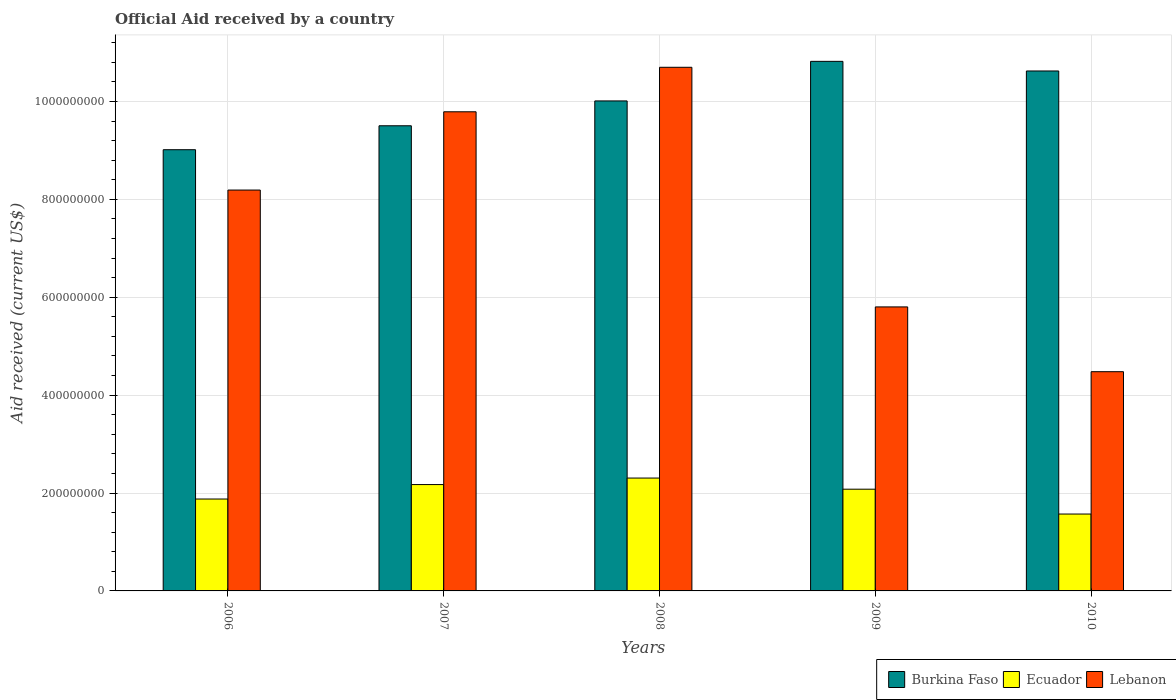How many different coloured bars are there?
Offer a terse response. 3. How many groups of bars are there?
Give a very brief answer. 5. Are the number of bars per tick equal to the number of legend labels?
Give a very brief answer. Yes. Are the number of bars on each tick of the X-axis equal?
Offer a terse response. Yes. How many bars are there on the 3rd tick from the right?
Provide a short and direct response. 3. What is the label of the 2nd group of bars from the left?
Your response must be concise. 2007. What is the net official aid received in Burkina Faso in 2008?
Provide a short and direct response. 1.00e+09. Across all years, what is the maximum net official aid received in Burkina Faso?
Provide a succinct answer. 1.08e+09. Across all years, what is the minimum net official aid received in Lebanon?
Keep it short and to the point. 4.48e+08. In which year was the net official aid received in Ecuador maximum?
Your answer should be compact. 2008. In which year was the net official aid received in Ecuador minimum?
Provide a short and direct response. 2010. What is the total net official aid received in Burkina Faso in the graph?
Keep it short and to the point. 5.00e+09. What is the difference between the net official aid received in Ecuador in 2007 and that in 2008?
Provide a short and direct response. -1.33e+07. What is the difference between the net official aid received in Lebanon in 2008 and the net official aid received in Ecuador in 2006?
Offer a terse response. 8.82e+08. What is the average net official aid received in Ecuador per year?
Offer a terse response. 2.00e+08. In the year 2008, what is the difference between the net official aid received in Burkina Faso and net official aid received in Ecuador?
Provide a short and direct response. 7.71e+08. In how many years, is the net official aid received in Ecuador greater than 640000000 US$?
Keep it short and to the point. 0. What is the ratio of the net official aid received in Lebanon in 2008 to that in 2009?
Ensure brevity in your answer.  1.84. Is the net official aid received in Lebanon in 2009 less than that in 2010?
Your answer should be compact. No. What is the difference between the highest and the second highest net official aid received in Ecuador?
Make the answer very short. 1.33e+07. What is the difference between the highest and the lowest net official aid received in Burkina Faso?
Provide a succinct answer. 1.81e+08. In how many years, is the net official aid received in Burkina Faso greater than the average net official aid received in Burkina Faso taken over all years?
Provide a short and direct response. 3. What does the 2nd bar from the left in 2006 represents?
Give a very brief answer. Ecuador. What does the 1st bar from the right in 2010 represents?
Your answer should be very brief. Lebanon. How many bars are there?
Your response must be concise. 15. Are the values on the major ticks of Y-axis written in scientific E-notation?
Provide a succinct answer. No. Does the graph contain any zero values?
Ensure brevity in your answer.  No. Where does the legend appear in the graph?
Ensure brevity in your answer.  Bottom right. How many legend labels are there?
Your answer should be compact. 3. What is the title of the graph?
Provide a short and direct response. Official Aid received by a country. What is the label or title of the Y-axis?
Ensure brevity in your answer.  Aid received (current US$). What is the Aid received (current US$) of Burkina Faso in 2006?
Your answer should be compact. 9.01e+08. What is the Aid received (current US$) in Ecuador in 2006?
Offer a very short reply. 1.88e+08. What is the Aid received (current US$) of Lebanon in 2006?
Make the answer very short. 8.19e+08. What is the Aid received (current US$) in Burkina Faso in 2007?
Offer a terse response. 9.50e+08. What is the Aid received (current US$) in Ecuador in 2007?
Ensure brevity in your answer.  2.17e+08. What is the Aid received (current US$) in Lebanon in 2007?
Provide a succinct answer. 9.79e+08. What is the Aid received (current US$) of Burkina Faso in 2008?
Your answer should be compact. 1.00e+09. What is the Aid received (current US$) of Ecuador in 2008?
Keep it short and to the point. 2.31e+08. What is the Aid received (current US$) of Lebanon in 2008?
Make the answer very short. 1.07e+09. What is the Aid received (current US$) of Burkina Faso in 2009?
Ensure brevity in your answer.  1.08e+09. What is the Aid received (current US$) of Ecuador in 2009?
Your answer should be very brief. 2.08e+08. What is the Aid received (current US$) in Lebanon in 2009?
Provide a short and direct response. 5.80e+08. What is the Aid received (current US$) of Burkina Faso in 2010?
Keep it short and to the point. 1.06e+09. What is the Aid received (current US$) in Ecuador in 2010?
Offer a very short reply. 1.57e+08. What is the Aid received (current US$) in Lebanon in 2010?
Offer a very short reply. 4.48e+08. Across all years, what is the maximum Aid received (current US$) of Burkina Faso?
Ensure brevity in your answer.  1.08e+09. Across all years, what is the maximum Aid received (current US$) of Ecuador?
Offer a terse response. 2.31e+08. Across all years, what is the maximum Aid received (current US$) of Lebanon?
Provide a succinct answer. 1.07e+09. Across all years, what is the minimum Aid received (current US$) in Burkina Faso?
Your answer should be very brief. 9.01e+08. Across all years, what is the minimum Aid received (current US$) of Ecuador?
Your response must be concise. 1.57e+08. Across all years, what is the minimum Aid received (current US$) of Lebanon?
Your response must be concise. 4.48e+08. What is the total Aid received (current US$) of Burkina Faso in the graph?
Your response must be concise. 5.00e+09. What is the total Aid received (current US$) of Ecuador in the graph?
Provide a short and direct response. 1.00e+09. What is the total Aid received (current US$) of Lebanon in the graph?
Your answer should be very brief. 3.90e+09. What is the difference between the Aid received (current US$) in Burkina Faso in 2006 and that in 2007?
Offer a terse response. -4.89e+07. What is the difference between the Aid received (current US$) of Ecuador in 2006 and that in 2007?
Your response must be concise. -2.95e+07. What is the difference between the Aid received (current US$) of Lebanon in 2006 and that in 2007?
Give a very brief answer. -1.60e+08. What is the difference between the Aid received (current US$) of Burkina Faso in 2006 and that in 2008?
Provide a short and direct response. -9.97e+07. What is the difference between the Aid received (current US$) of Ecuador in 2006 and that in 2008?
Keep it short and to the point. -4.28e+07. What is the difference between the Aid received (current US$) of Lebanon in 2006 and that in 2008?
Your answer should be very brief. -2.51e+08. What is the difference between the Aid received (current US$) in Burkina Faso in 2006 and that in 2009?
Offer a very short reply. -1.81e+08. What is the difference between the Aid received (current US$) of Ecuador in 2006 and that in 2009?
Give a very brief answer. -2.01e+07. What is the difference between the Aid received (current US$) in Lebanon in 2006 and that in 2009?
Offer a very short reply. 2.39e+08. What is the difference between the Aid received (current US$) in Burkina Faso in 2006 and that in 2010?
Make the answer very short. -1.61e+08. What is the difference between the Aid received (current US$) in Ecuador in 2006 and that in 2010?
Provide a short and direct response. 3.07e+07. What is the difference between the Aid received (current US$) in Lebanon in 2006 and that in 2010?
Ensure brevity in your answer.  3.71e+08. What is the difference between the Aid received (current US$) in Burkina Faso in 2007 and that in 2008?
Offer a terse response. -5.08e+07. What is the difference between the Aid received (current US$) in Ecuador in 2007 and that in 2008?
Offer a very short reply. -1.33e+07. What is the difference between the Aid received (current US$) of Lebanon in 2007 and that in 2008?
Keep it short and to the point. -9.09e+07. What is the difference between the Aid received (current US$) in Burkina Faso in 2007 and that in 2009?
Provide a short and direct response. -1.32e+08. What is the difference between the Aid received (current US$) of Ecuador in 2007 and that in 2009?
Offer a terse response. 9.44e+06. What is the difference between the Aid received (current US$) in Lebanon in 2007 and that in 2009?
Your answer should be very brief. 3.99e+08. What is the difference between the Aid received (current US$) of Burkina Faso in 2007 and that in 2010?
Your response must be concise. -1.12e+08. What is the difference between the Aid received (current US$) in Ecuador in 2007 and that in 2010?
Ensure brevity in your answer.  6.02e+07. What is the difference between the Aid received (current US$) in Lebanon in 2007 and that in 2010?
Provide a succinct answer. 5.31e+08. What is the difference between the Aid received (current US$) in Burkina Faso in 2008 and that in 2009?
Make the answer very short. -8.08e+07. What is the difference between the Aid received (current US$) in Ecuador in 2008 and that in 2009?
Offer a very short reply. 2.28e+07. What is the difference between the Aid received (current US$) of Lebanon in 2008 and that in 2009?
Offer a terse response. 4.90e+08. What is the difference between the Aid received (current US$) in Burkina Faso in 2008 and that in 2010?
Your answer should be compact. -6.12e+07. What is the difference between the Aid received (current US$) in Ecuador in 2008 and that in 2010?
Offer a very short reply. 7.35e+07. What is the difference between the Aid received (current US$) of Lebanon in 2008 and that in 2010?
Your answer should be compact. 6.22e+08. What is the difference between the Aid received (current US$) in Burkina Faso in 2009 and that in 2010?
Provide a short and direct response. 1.97e+07. What is the difference between the Aid received (current US$) of Ecuador in 2009 and that in 2010?
Provide a succinct answer. 5.08e+07. What is the difference between the Aid received (current US$) in Lebanon in 2009 and that in 2010?
Offer a terse response. 1.32e+08. What is the difference between the Aid received (current US$) in Burkina Faso in 2006 and the Aid received (current US$) in Ecuador in 2007?
Provide a succinct answer. 6.84e+08. What is the difference between the Aid received (current US$) of Burkina Faso in 2006 and the Aid received (current US$) of Lebanon in 2007?
Provide a short and direct response. -7.75e+07. What is the difference between the Aid received (current US$) of Ecuador in 2006 and the Aid received (current US$) of Lebanon in 2007?
Offer a very short reply. -7.91e+08. What is the difference between the Aid received (current US$) in Burkina Faso in 2006 and the Aid received (current US$) in Ecuador in 2008?
Provide a short and direct response. 6.71e+08. What is the difference between the Aid received (current US$) of Burkina Faso in 2006 and the Aid received (current US$) of Lebanon in 2008?
Offer a terse response. -1.68e+08. What is the difference between the Aid received (current US$) of Ecuador in 2006 and the Aid received (current US$) of Lebanon in 2008?
Offer a very short reply. -8.82e+08. What is the difference between the Aid received (current US$) in Burkina Faso in 2006 and the Aid received (current US$) in Ecuador in 2009?
Provide a short and direct response. 6.94e+08. What is the difference between the Aid received (current US$) in Burkina Faso in 2006 and the Aid received (current US$) in Lebanon in 2009?
Provide a short and direct response. 3.21e+08. What is the difference between the Aid received (current US$) of Ecuador in 2006 and the Aid received (current US$) of Lebanon in 2009?
Ensure brevity in your answer.  -3.93e+08. What is the difference between the Aid received (current US$) of Burkina Faso in 2006 and the Aid received (current US$) of Ecuador in 2010?
Offer a terse response. 7.44e+08. What is the difference between the Aid received (current US$) of Burkina Faso in 2006 and the Aid received (current US$) of Lebanon in 2010?
Offer a very short reply. 4.54e+08. What is the difference between the Aid received (current US$) of Ecuador in 2006 and the Aid received (current US$) of Lebanon in 2010?
Provide a succinct answer. -2.60e+08. What is the difference between the Aid received (current US$) in Burkina Faso in 2007 and the Aid received (current US$) in Ecuador in 2008?
Make the answer very short. 7.20e+08. What is the difference between the Aid received (current US$) in Burkina Faso in 2007 and the Aid received (current US$) in Lebanon in 2008?
Provide a short and direct response. -1.19e+08. What is the difference between the Aid received (current US$) of Ecuador in 2007 and the Aid received (current US$) of Lebanon in 2008?
Your answer should be compact. -8.53e+08. What is the difference between the Aid received (current US$) of Burkina Faso in 2007 and the Aid received (current US$) of Ecuador in 2009?
Ensure brevity in your answer.  7.43e+08. What is the difference between the Aid received (current US$) of Burkina Faso in 2007 and the Aid received (current US$) of Lebanon in 2009?
Make the answer very short. 3.70e+08. What is the difference between the Aid received (current US$) in Ecuador in 2007 and the Aid received (current US$) in Lebanon in 2009?
Offer a very short reply. -3.63e+08. What is the difference between the Aid received (current US$) of Burkina Faso in 2007 and the Aid received (current US$) of Ecuador in 2010?
Provide a succinct answer. 7.93e+08. What is the difference between the Aid received (current US$) in Burkina Faso in 2007 and the Aid received (current US$) in Lebanon in 2010?
Your answer should be compact. 5.02e+08. What is the difference between the Aid received (current US$) in Ecuador in 2007 and the Aid received (current US$) in Lebanon in 2010?
Your response must be concise. -2.31e+08. What is the difference between the Aid received (current US$) in Burkina Faso in 2008 and the Aid received (current US$) in Ecuador in 2009?
Keep it short and to the point. 7.93e+08. What is the difference between the Aid received (current US$) in Burkina Faso in 2008 and the Aid received (current US$) in Lebanon in 2009?
Provide a short and direct response. 4.21e+08. What is the difference between the Aid received (current US$) of Ecuador in 2008 and the Aid received (current US$) of Lebanon in 2009?
Give a very brief answer. -3.50e+08. What is the difference between the Aid received (current US$) in Burkina Faso in 2008 and the Aid received (current US$) in Ecuador in 2010?
Your answer should be compact. 8.44e+08. What is the difference between the Aid received (current US$) of Burkina Faso in 2008 and the Aid received (current US$) of Lebanon in 2010?
Provide a short and direct response. 5.53e+08. What is the difference between the Aid received (current US$) of Ecuador in 2008 and the Aid received (current US$) of Lebanon in 2010?
Provide a succinct answer. -2.17e+08. What is the difference between the Aid received (current US$) of Burkina Faso in 2009 and the Aid received (current US$) of Ecuador in 2010?
Your answer should be very brief. 9.25e+08. What is the difference between the Aid received (current US$) in Burkina Faso in 2009 and the Aid received (current US$) in Lebanon in 2010?
Make the answer very short. 6.34e+08. What is the difference between the Aid received (current US$) of Ecuador in 2009 and the Aid received (current US$) of Lebanon in 2010?
Provide a succinct answer. -2.40e+08. What is the average Aid received (current US$) of Burkina Faso per year?
Provide a succinct answer. 9.99e+08. What is the average Aid received (current US$) of Ecuador per year?
Offer a terse response. 2.00e+08. What is the average Aid received (current US$) in Lebanon per year?
Provide a succinct answer. 7.79e+08. In the year 2006, what is the difference between the Aid received (current US$) of Burkina Faso and Aid received (current US$) of Ecuador?
Keep it short and to the point. 7.14e+08. In the year 2006, what is the difference between the Aid received (current US$) of Burkina Faso and Aid received (current US$) of Lebanon?
Provide a succinct answer. 8.24e+07. In the year 2006, what is the difference between the Aid received (current US$) of Ecuador and Aid received (current US$) of Lebanon?
Your answer should be very brief. -6.31e+08. In the year 2007, what is the difference between the Aid received (current US$) of Burkina Faso and Aid received (current US$) of Ecuador?
Provide a succinct answer. 7.33e+08. In the year 2007, what is the difference between the Aid received (current US$) in Burkina Faso and Aid received (current US$) in Lebanon?
Your answer should be very brief. -2.86e+07. In the year 2007, what is the difference between the Aid received (current US$) in Ecuador and Aid received (current US$) in Lebanon?
Your answer should be compact. -7.62e+08. In the year 2008, what is the difference between the Aid received (current US$) in Burkina Faso and Aid received (current US$) in Ecuador?
Your response must be concise. 7.71e+08. In the year 2008, what is the difference between the Aid received (current US$) of Burkina Faso and Aid received (current US$) of Lebanon?
Keep it short and to the point. -6.87e+07. In the year 2008, what is the difference between the Aid received (current US$) of Ecuador and Aid received (current US$) of Lebanon?
Your answer should be compact. -8.39e+08. In the year 2009, what is the difference between the Aid received (current US$) of Burkina Faso and Aid received (current US$) of Ecuador?
Keep it short and to the point. 8.74e+08. In the year 2009, what is the difference between the Aid received (current US$) of Burkina Faso and Aid received (current US$) of Lebanon?
Your answer should be very brief. 5.02e+08. In the year 2009, what is the difference between the Aid received (current US$) of Ecuador and Aid received (current US$) of Lebanon?
Offer a terse response. -3.72e+08. In the year 2010, what is the difference between the Aid received (current US$) in Burkina Faso and Aid received (current US$) in Ecuador?
Your response must be concise. 9.05e+08. In the year 2010, what is the difference between the Aid received (current US$) of Burkina Faso and Aid received (current US$) of Lebanon?
Provide a succinct answer. 6.14e+08. In the year 2010, what is the difference between the Aid received (current US$) in Ecuador and Aid received (current US$) in Lebanon?
Provide a succinct answer. -2.91e+08. What is the ratio of the Aid received (current US$) in Burkina Faso in 2006 to that in 2007?
Your answer should be compact. 0.95. What is the ratio of the Aid received (current US$) in Ecuador in 2006 to that in 2007?
Provide a short and direct response. 0.86. What is the ratio of the Aid received (current US$) in Lebanon in 2006 to that in 2007?
Your response must be concise. 0.84. What is the ratio of the Aid received (current US$) of Burkina Faso in 2006 to that in 2008?
Provide a short and direct response. 0.9. What is the ratio of the Aid received (current US$) in Ecuador in 2006 to that in 2008?
Provide a short and direct response. 0.81. What is the ratio of the Aid received (current US$) of Lebanon in 2006 to that in 2008?
Offer a very short reply. 0.77. What is the ratio of the Aid received (current US$) of Burkina Faso in 2006 to that in 2009?
Keep it short and to the point. 0.83. What is the ratio of the Aid received (current US$) of Ecuador in 2006 to that in 2009?
Your answer should be very brief. 0.9. What is the ratio of the Aid received (current US$) in Lebanon in 2006 to that in 2009?
Ensure brevity in your answer.  1.41. What is the ratio of the Aid received (current US$) in Burkina Faso in 2006 to that in 2010?
Provide a succinct answer. 0.85. What is the ratio of the Aid received (current US$) in Ecuador in 2006 to that in 2010?
Your answer should be very brief. 1.2. What is the ratio of the Aid received (current US$) of Lebanon in 2006 to that in 2010?
Your answer should be compact. 1.83. What is the ratio of the Aid received (current US$) in Burkina Faso in 2007 to that in 2008?
Ensure brevity in your answer.  0.95. What is the ratio of the Aid received (current US$) in Ecuador in 2007 to that in 2008?
Provide a succinct answer. 0.94. What is the ratio of the Aid received (current US$) of Lebanon in 2007 to that in 2008?
Your answer should be compact. 0.92. What is the ratio of the Aid received (current US$) in Burkina Faso in 2007 to that in 2009?
Keep it short and to the point. 0.88. What is the ratio of the Aid received (current US$) of Ecuador in 2007 to that in 2009?
Offer a very short reply. 1.05. What is the ratio of the Aid received (current US$) of Lebanon in 2007 to that in 2009?
Keep it short and to the point. 1.69. What is the ratio of the Aid received (current US$) in Burkina Faso in 2007 to that in 2010?
Make the answer very short. 0.89. What is the ratio of the Aid received (current US$) of Ecuador in 2007 to that in 2010?
Offer a very short reply. 1.38. What is the ratio of the Aid received (current US$) in Lebanon in 2007 to that in 2010?
Keep it short and to the point. 2.19. What is the ratio of the Aid received (current US$) in Burkina Faso in 2008 to that in 2009?
Your answer should be compact. 0.93. What is the ratio of the Aid received (current US$) of Ecuador in 2008 to that in 2009?
Provide a succinct answer. 1.11. What is the ratio of the Aid received (current US$) of Lebanon in 2008 to that in 2009?
Keep it short and to the point. 1.84. What is the ratio of the Aid received (current US$) in Burkina Faso in 2008 to that in 2010?
Offer a terse response. 0.94. What is the ratio of the Aid received (current US$) of Ecuador in 2008 to that in 2010?
Offer a terse response. 1.47. What is the ratio of the Aid received (current US$) in Lebanon in 2008 to that in 2010?
Provide a short and direct response. 2.39. What is the ratio of the Aid received (current US$) of Burkina Faso in 2009 to that in 2010?
Make the answer very short. 1.02. What is the ratio of the Aid received (current US$) of Ecuador in 2009 to that in 2010?
Your answer should be compact. 1.32. What is the ratio of the Aid received (current US$) in Lebanon in 2009 to that in 2010?
Give a very brief answer. 1.3. What is the difference between the highest and the second highest Aid received (current US$) in Burkina Faso?
Give a very brief answer. 1.97e+07. What is the difference between the highest and the second highest Aid received (current US$) of Ecuador?
Provide a succinct answer. 1.33e+07. What is the difference between the highest and the second highest Aid received (current US$) of Lebanon?
Make the answer very short. 9.09e+07. What is the difference between the highest and the lowest Aid received (current US$) in Burkina Faso?
Give a very brief answer. 1.81e+08. What is the difference between the highest and the lowest Aid received (current US$) of Ecuador?
Make the answer very short. 7.35e+07. What is the difference between the highest and the lowest Aid received (current US$) in Lebanon?
Keep it short and to the point. 6.22e+08. 